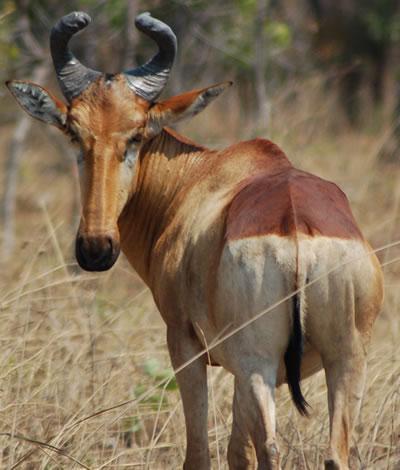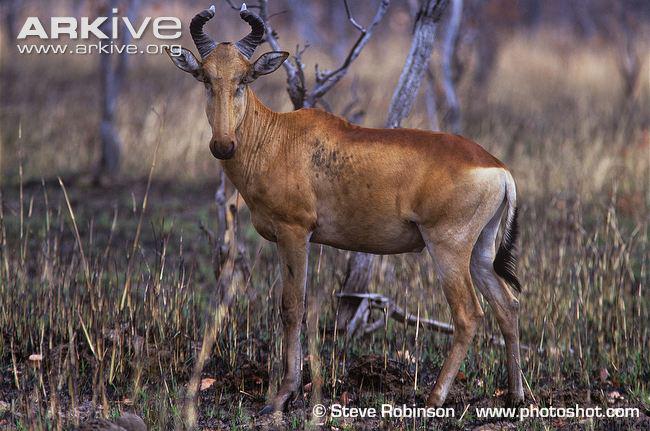The first image is the image on the left, the second image is the image on the right. Examine the images to the left and right. Is the description "There is a total of two elk." accurate? Answer yes or no. Yes. The first image is the image on the left, the second image is the image on the right. For the images displayed, is the sentence "There are exactly two animals standing." factually correct? Answer yes or no. Yes. 